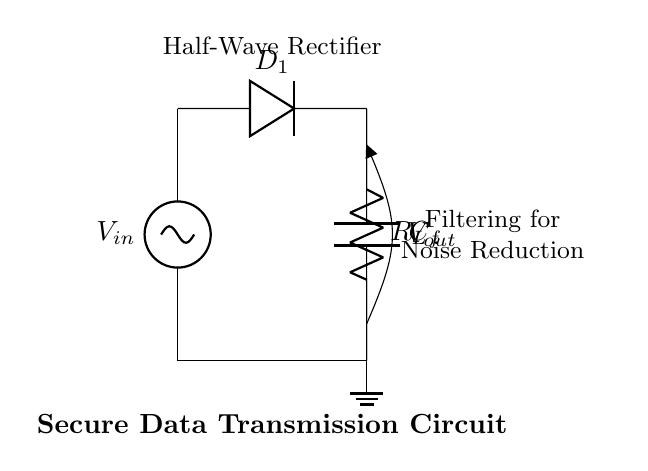What is the input voltage in the circuit? The input voltage is represented by the voltage source labeled as `V_in`, which is at the leftmost point of the circuit diagram.
Answer: V_in What components are used in this half-wave rectifier circuit? The circuit consists of a voltage source, a diode labeled as `D_1`, a load resistor labeled as `R_L`, and a filter capacitor labeled as `C_f`.
Answer: Voltage source, diode, load resistor, filter capacitor What does the diode in the circuit do? The diode, labeled as `D_1`, allows current to flow in one direction only, rectifying the input AC voltage to a pulsating DC output.
Answer: Rectifies current How does the capacitor contribute to noise reduction? The capacitor labeled as `C_f` smoothens the output voltage by charging during the peaks of the rectified waveform and discharging when the voltage drops, thus reducing fluctuations in output.
Answer: Smoothens output voltage What type of rectifier is shown in this circuit? The circuit is identified as a half-wave rectifier because it only allows one half of the AC input signal to pass through, resulting in a pulsating DC output.
Answer: Half-wave rectifier How does the filter capacitor impact the output voltage waveform? The filter capacitor `C_f` charges to the peak voltage during the conduction phase of the diode and discharges when no voltage is present, creating a smoother output waveform and reducing noise in sensitive applications.
Answer: Creates smoother waveform What is the purpose of the load resistor in the circuit? The load resistor `R_L` is used to limit the current drawn from the circuit and provides a path for the load equipment to operate, ensuring the proper functioning of the rectifier-output.
Answer: Limits current 